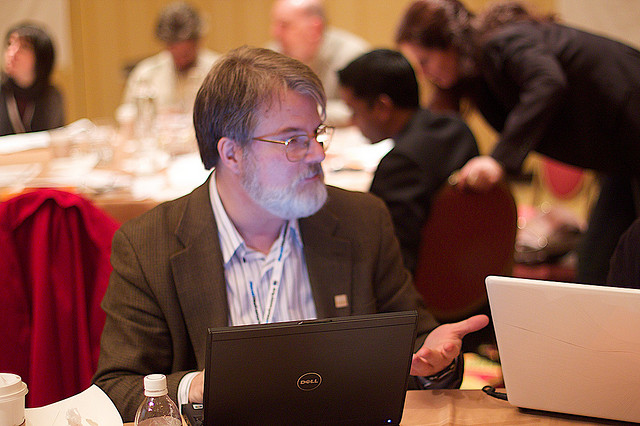Identify the text contained in this image. DOLL 